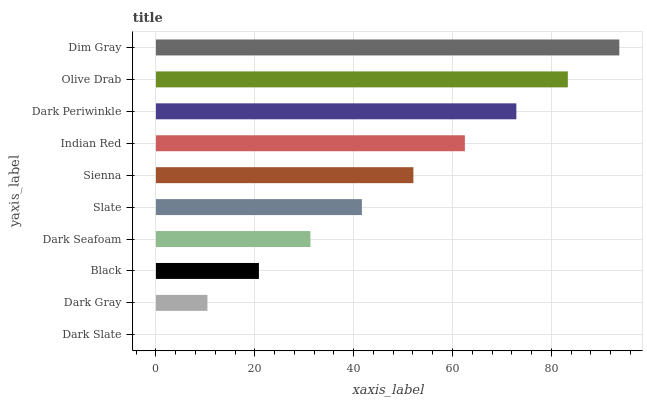Is Dark Slate the minimum?
Answer yes or no. Yes. Is Dim Gray the maximum?
Answer yes or no. Yes. Is Dark Gray the minimum?
Answer yes or no. No. Is Dark Gray the maximum?
Answer yes or no. No. Is Dark Gray greater than Dark Slate?
Answer yes or no. Yes. Is Dark Slate less than Dark Gray?
Answer yes or no. Yes. Is Dark Slate greater than Dark Gray?
Answer yes or no. No. Is Dark Gray less than Dark Slate?
Answer yes or no. No. Is Sienna the high median?
Answer yes or no. Yes. Is Slate the low median?
Answer yes or no. Yes. Is Dark Seafoam the high median?
Answer yes or no. No. Is Black the low median?
Answer yes or no. No. 